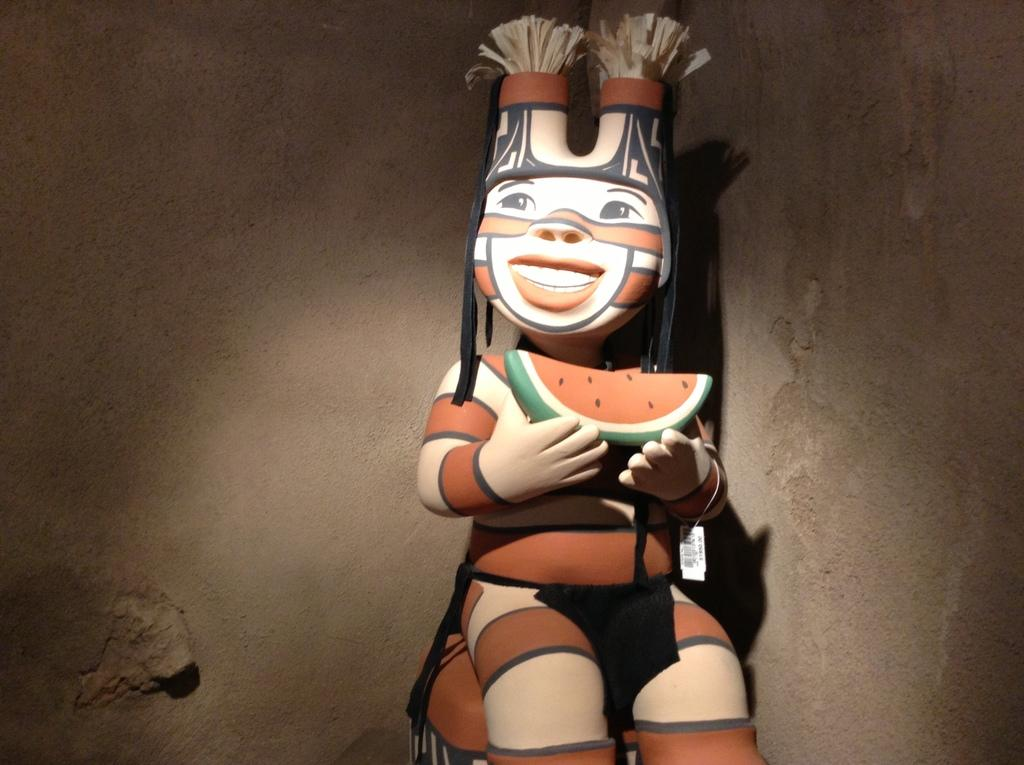What is the main subject of the image? There is a toy in the center of the image. How many boys are playing with the toy in the image? There are no boys present in the image; it only features a toy. What is the name of the creator of the toy in the image? There is no information about the creator of the toy in the image. 